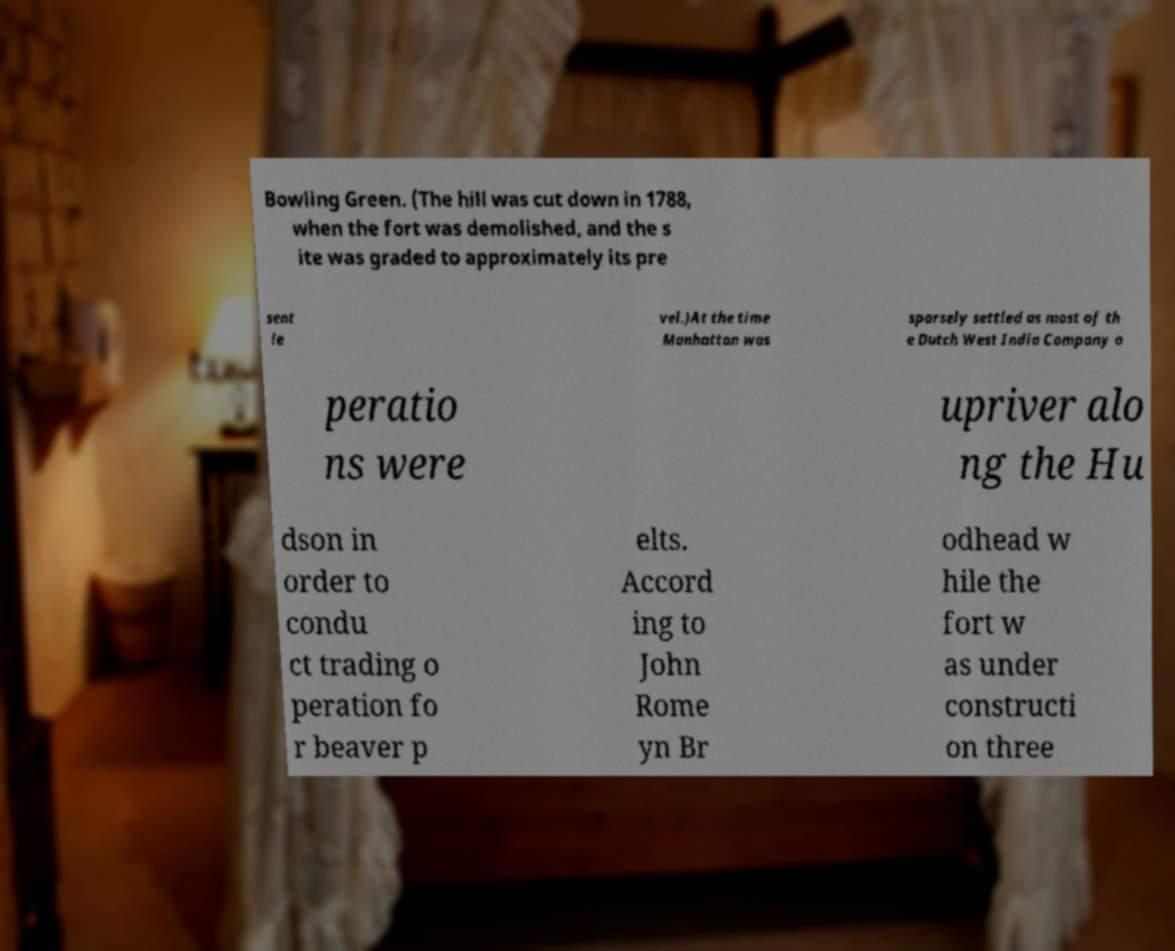For documentation purposes, I need the text within this image transcribed. Could you provide that? Bowling Green. (The hill was cut down in 1788, when the fort was demolished, and the s ite was graded to approximately its pre sent le vel.)At the time Manhattan was sparsely settled as most of th e Dutch West India Company o peratio ns were upriver alo ng the Hu dson in order to condu ct trading o peration fo r beaver p elts. Accord ing to John Rome yn Br odhead w hile the fort w as under constructi on three 